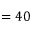Convert formula to latex. <formula><loc_0><loc_0><loc_500><loc_500>= 4 0</formula> 